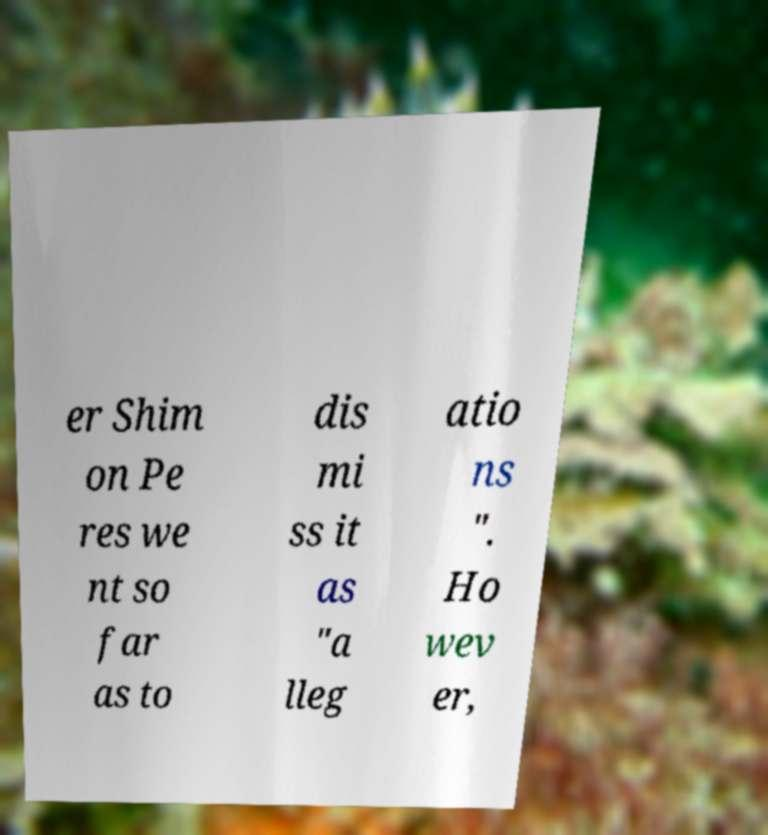Can you accurately transcribe the text from the provided image for me? er Shim on Pe res we nt so far as to dis mi ss it as "a lleg atio ns ". Ho wev er, 